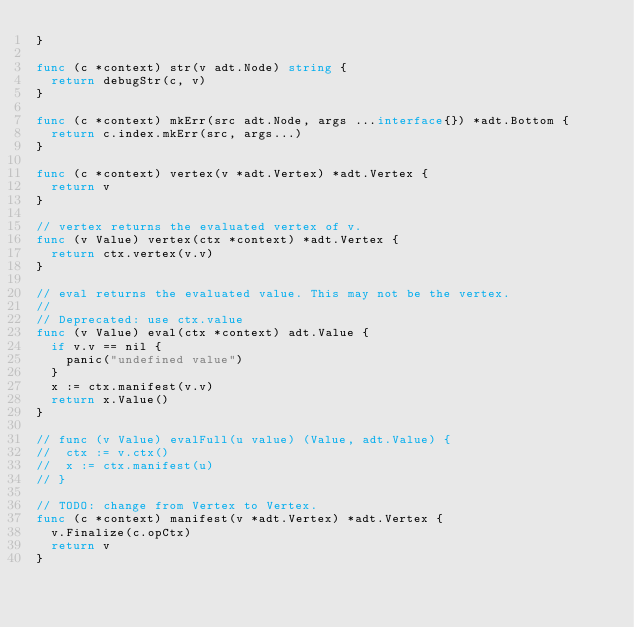Convert code to text. <code><loc_0><loc_0><loc_500><loc_500><_Go_>}

func (c *context) str(v adt.Node) string {
	return debugStr(c, v)
}

func (c *context) mkErr(src adt.Node, args ...interface{}) *adt.Bottom {
	return c.index.mkErr(src, args...)
}

func (c *context) vertex(v *adt.Vertex) *adt.Vertex {
	return v
}

// vertex returns the evaluated vertex of v.
func (v Value) vertex(ctx *context) *adt.Vertex {
	return ctx.vertex(v.v)
}

// eval returns the evaluated value. This may not be the vertex.
//
// Deprecated: use ctx.value
func (v Value) eval(ctx *context) adt.Value {
	if v.v == nil {
		panic("undefined value")
	}
	x := ctx.manifest(v.v)
	return x.Value()
}

// func (v Value) evalFull(u value) (Value, adt.Value) {
// 	ctx := v.ctx()
// 	x := ctx.manifest(u)
// }

// TODO: change from Vertex to Vertex.
func (c *context) manifest(v *adt.Vertex) *adt.Vertex {
	v.Finalize(c.opCtx)
	return v
}
</code> 